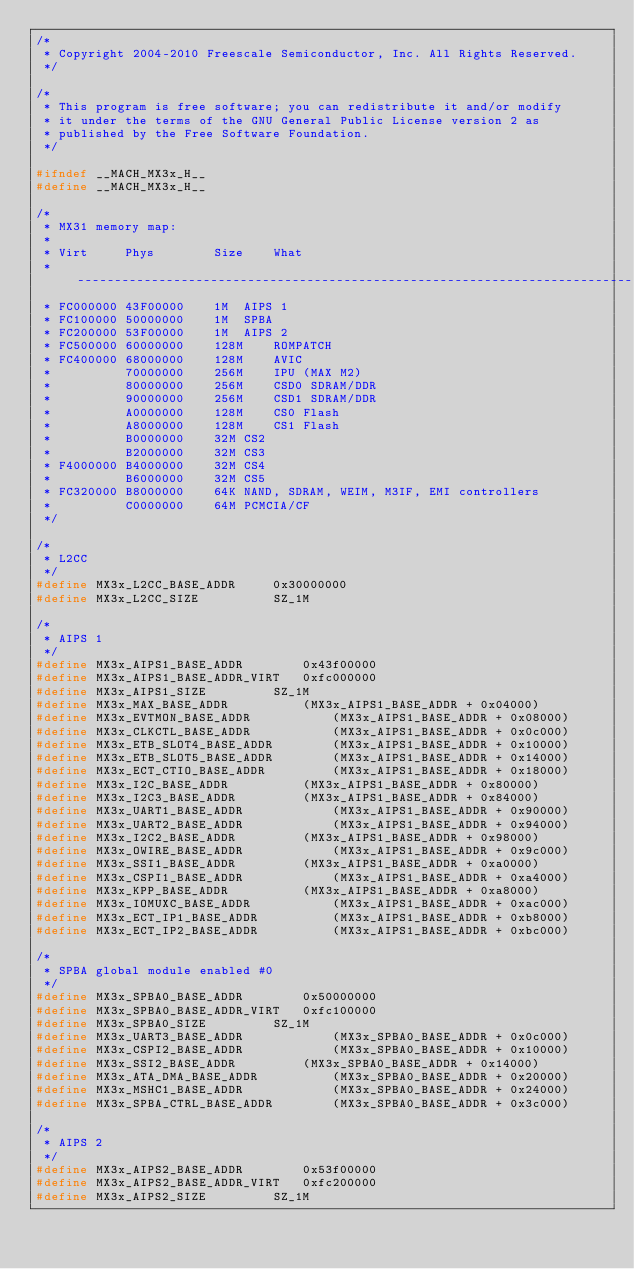Convert code to text. <code><loc_0><loc_0><loc_500><loc_500><_C_>/*
 * Copyright 2004-2010 Freescale Semiconductor, Inc. All Rights Reserved.
 */

/*
 * This program is free software; you can redistribute it and/or modify
 * it under the terms of the GNU General Public License version 2 as
 * published by the Free Software Foundation.
 */

#ifndef __MACH_MX3x_H__
#define __MACH_MX3x_H__

/*
 * MX31 memory map:
 *
 * Virt		Phys		Size	What
 * ---------------------------------------------------------------------------
 * FC000000	43F00000	1M	AIPS 1
 * FC100000	50000000	1M	SPBA
 * FC200000	53F00000	1M	AIPS 2
 * FC500000	60000000	128M	ROMPATCH
 * FC400000	68000000	128M	AVIC
 *         	70000000	256M	IPU (MAX M2)
 *         	80000000	256M	CSD0 SDRAM/DDR
 *         	90000000	256M	CSD1 SDRAM/DDR
 *         	A0000000	128M	CS0 Flash
 *         	A8000000	128M	CS1 Flash
 *         	B0000000	32M	CS2
 *         	B2000000	32M	CS3
 * F4000000	B4000000	32M	CS4
 *         	B6000000	32M	CS5
 * FC320000	B8000000	64K	NAND, SDRAM, WEIM, M3IF, EMI controllers
 *         	C0000000	64M	PCMCIA/CF
 */

/*
 * L2CC
 */
#define MX3x_L2CC_BASE_ADDR		0x30000000
#define MX3x_L2CC_SIZE			SZ_1M

/*
 * AIPS 1
 */
#define MX3x_AIPS1_BASE_ADDR		0x43f00000
#define MX3x_AIPS1_BASE_ADDR_VIRT	0xfc000000
#define MX3x_AIPS1_SIZE			SZ_1M
#define MX3x_MAX_BASE_ADDR			(MX3x_AIPS1_BASE_ADDR + 0x04000)
#define MX3x_EVTMON_BASE_ADDR			(MX3x_AIPS1_BASE_ADDR + 0x08000)
#define MX3x_CLKCTL_BASE_ADDR			(MX3x_AIPS1_BASE_ADDR + 0x0c000)
#define MX3x_ETB_SLOT4_BASE_ADDR		(MX3x_AIPS1_BASE_ADDR + 0x10000)
#define MX3x_ETB_SLOT5_BASE_ADDR		(MX3x_AIPS1_BASE_ADDR + 0x14000)
#define MX3x_ECT_CTIO_BASE_ADDR			(MX3x_AIPS1_BASE_ADDR + 0x18000)
#define MX3x_I2C_BASE_ADDR			(MX3x_AIPS1_BASE_ADDR + 0x80000)
#define MX3x_I2C3_BASE_ADDR			(MX3x_AIPS1_BASE_ADDR + 0x84000)
#define MX3x_UART1_BASE_ADDR			(MX3x_AIPS1_BASE_ADDR + 0x90000)
#define MX3x_UART2_BASE_ADDR			(MX3x_AIPS1_BASE_ADDR + 0x94000)
#define MX3x_I2C2_BASE_ADDR			(MX3x_AIPS1_BASE_ADDR + 0x98000)
#define MX3x_OWIRE_BASE_ADDR			(MX3x_AIPS1_BASE_ADDR + 0x9c000)
#define MX3x_SSI1_BASE_ADDR			(MX3x_AIPS1_BASE_ADDR + 0xa0000)
#define MX3x_CSPI1_BASE_ADDR			(MX3x_AIPS1_BASE_ADDR + 0xa4000)
#define MX3x_KPP_BASE_ADDR			(MX3x_AIPS1_BASE_ADDR + 0xa8000)
#define MX3x_IOMUXC_BASE_ADDR			(MX3x_AIPS1_BASE_ADDR + 0xac000)
#define MX3x_ECT_IP1_BASE_ADDR			(MX3x_AIPS1_BASE_ADDR + 0xb8000)
#define MX3x_ECT_IP2_BASE_ADDR			(MX3x_AIPS1_BASE_ADDR + 0xbc000)

/*
 * SPBA global module enabled #0
 */
#define MX3x_SPBA0_BASE_ADDR		0x50000000
#define MX3x_SPBA0_BASE_ADDR_VIRT	0xfc100000
#define MX3x_SPBA0_SIZE			SZ_1M
#define MX3x_UART3_BASE_ADDR			(MX3x_SPBA0_BASE_ADDR + 0x0c000)
#define MX3x_CSPI2_BASE_ADDR			(MX3x_SPBA0_BASE_ADDR + 0x10000)
#define MX3x_SSI2_BASE_ADDR			(MX3x_SPBA0_BASE_ADDR + 0x14000)
#define MX3x_ATA_DMA_BASE_ADDR			(MX3x_SPBA0_BASE_ADDR + 0x20000)
#define MX3x_MSHC1_BASE_ADDR			(MX3x_SPBA0_BASE_ADDR + 0x24000)
#define MX3x_SPBA_CTRL_BASE_ADDR		(MX3x_SPBA0_BASE_ADDR + 0x3c000)

/*
 * AIPS 2
 */
#define MX3x_AIPS2_BASE_ADDR		0x53f00000
#define MX3x_AIPS2_BASE_ADDR_VIRT	0xfc200000
#define MX3x_AIPS2_SIZE			SZ_1M</code> 